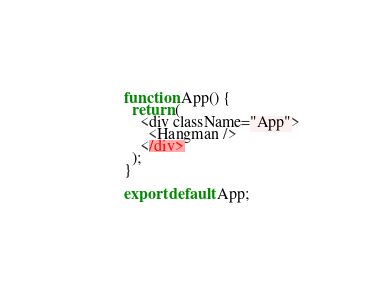Convert code to text. <code><loc_0><loc_0><loc_500><loc_500><_JavaScript_>
function App() {
  return (
    <div className="App">
      <Hangman />
    </div>
  );
}

export default App;
</code> 